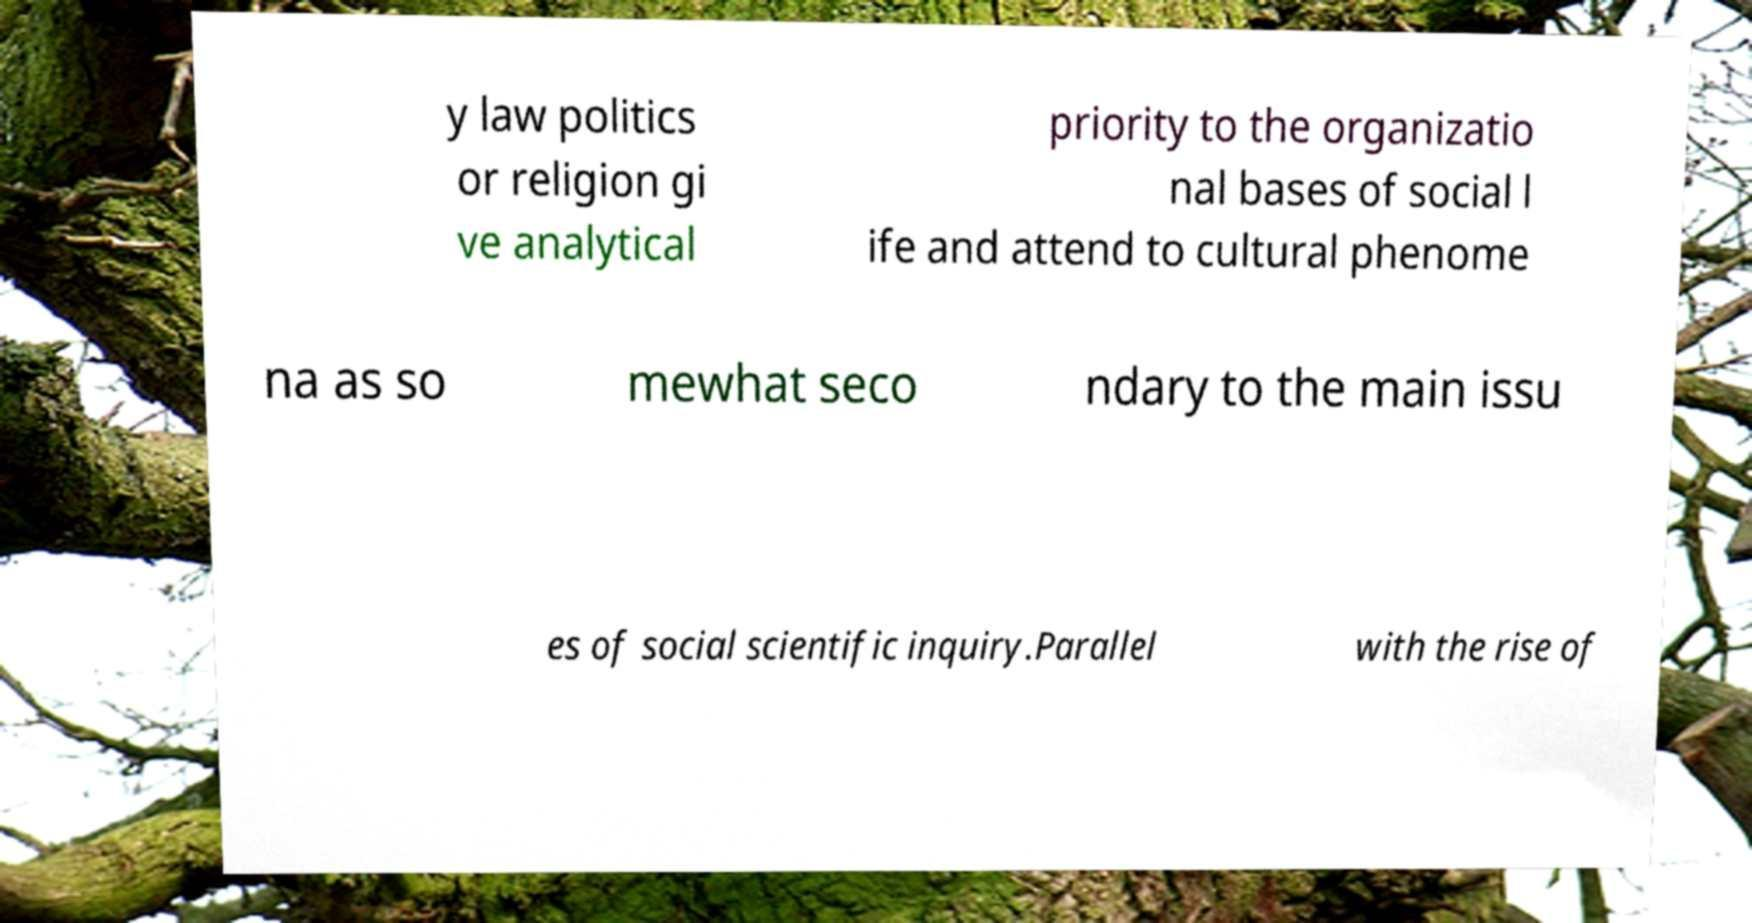Can you accurately transcribe the text from the provided image for me? y law politics or religion gi ve analytical priority to the organizatio nal bases of social l ife and attend to cultural phenome na as so mewhat seco ndary to the main issu es of social scientific inquiry.Parallel with the rise of 